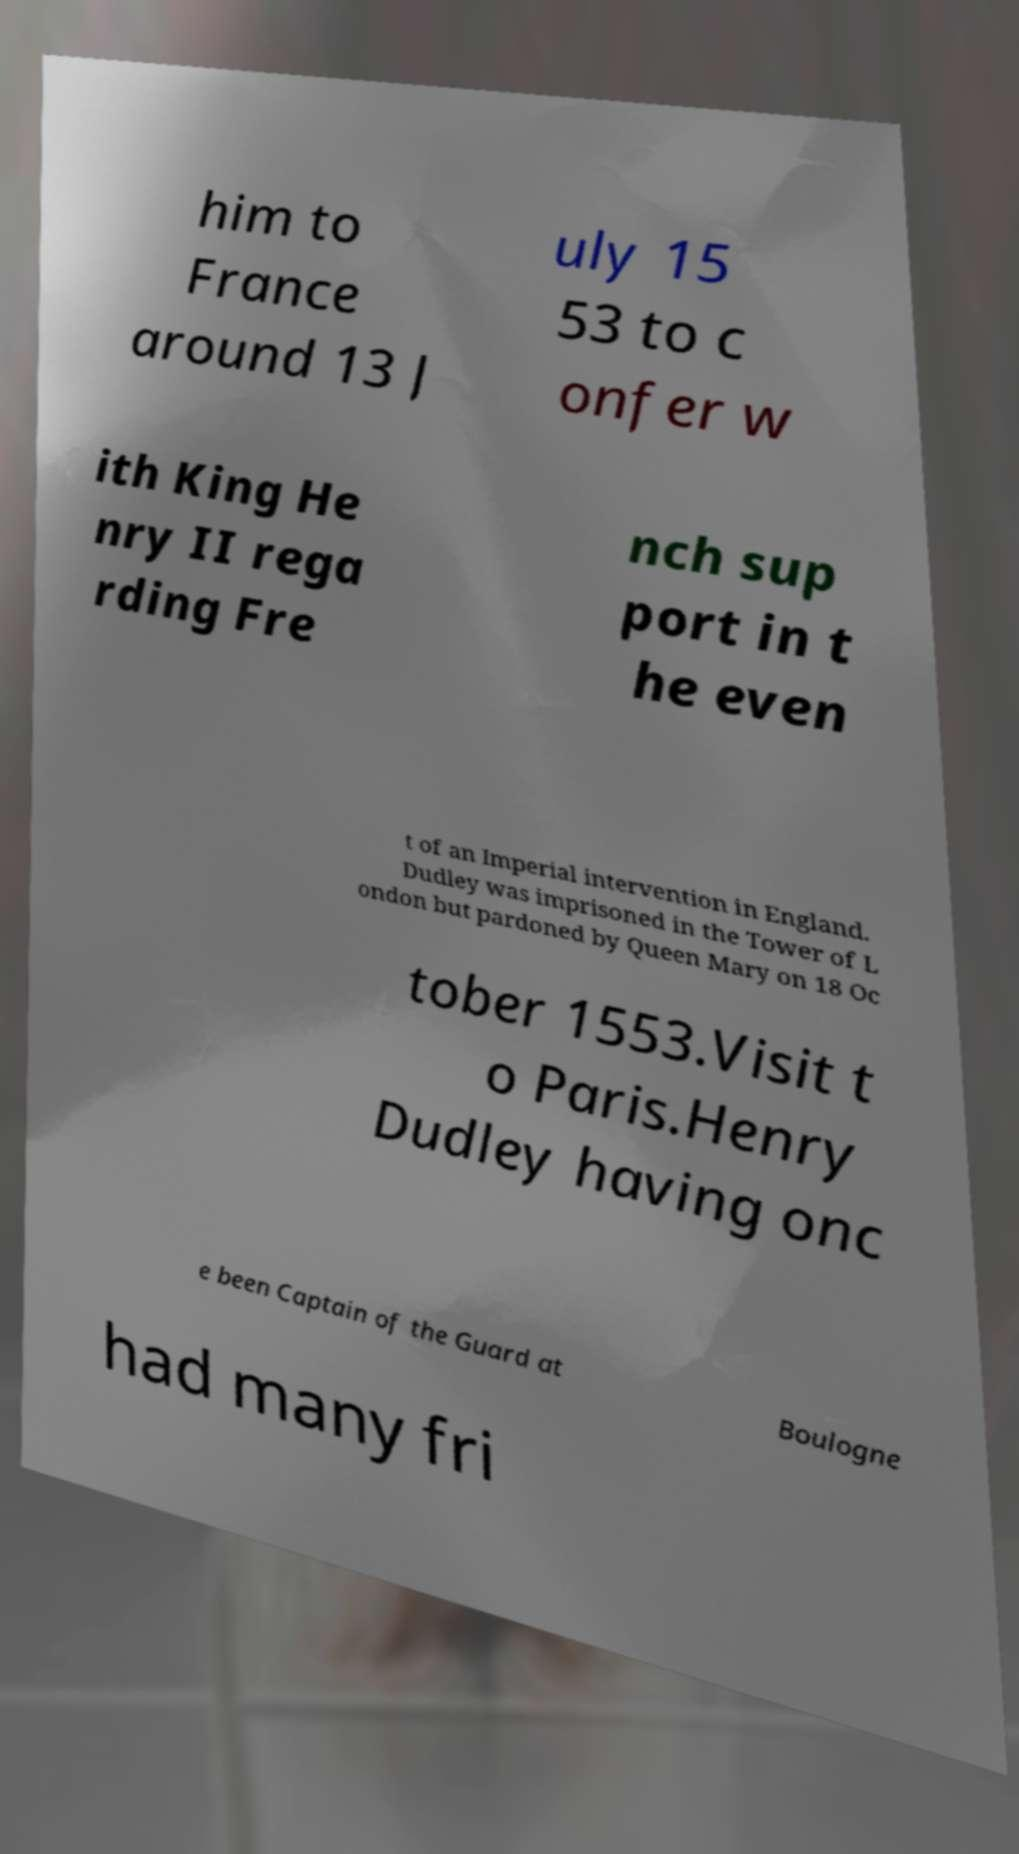Please read and relay the text visible in this image. What does it say? him to France around 13 J uly 15 53 to c onfer w ith King He nry II rega rding Fre nch sup port in t he even t of an Imperial intervention in England. Dudley was imprisoned in the Tower of L ondon but pardoned by Queen Mary on 18 Oc tober 1553.Visit t o Paris.Henry Dudley having onc e been Captain of the Guard at Boulogne had many fri 